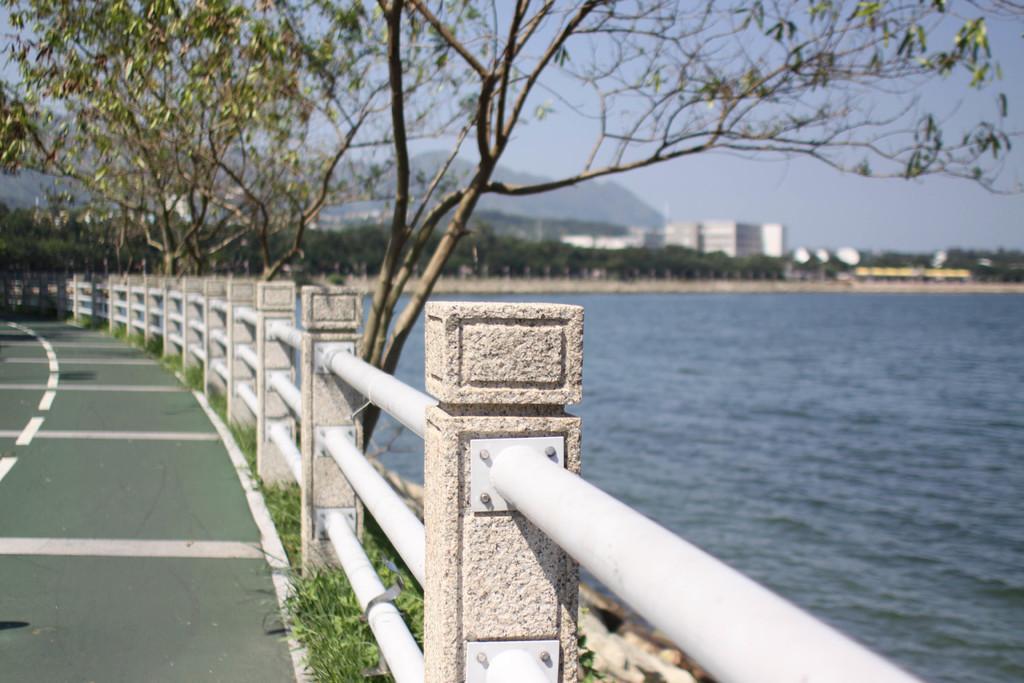In one or two sentences, can you explain what this image depicts? In this image in the center there is railing and some pillars, and on the right side of the image there is a river. And on the left side of the image there is a walkway and some grass, and in the background there are some trees, buildings, mountains and at the top there is sky. 